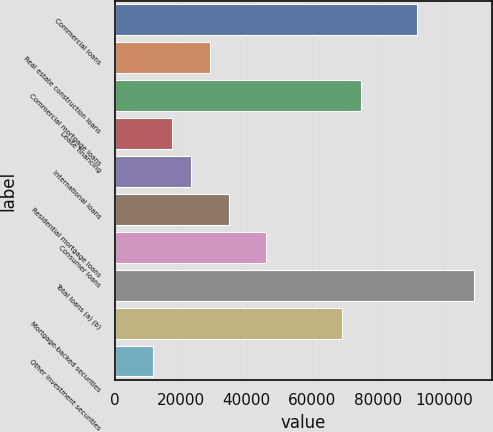<chart> <loc_0><loc_0><loc_500><loc_500><bar_chart><fcel>Commercial loans<fcel>Real estate construction loans<fcel>Commercial mortgage loans<fcel>Lease financing<fcel>International loans<fcel>Residential mortgage loans<fcel>Consumer loans<fcel>Total loans (a) (b)<fcel>Mortgage-backed securities<fcel>Other investment securities<nl><fcel>91892.4<fcel>28808.5<fcel>74687.7<fcel>17338.7<fcel>23073.6<fcel>34543.4<fcel>46013.2<fcel>109097<fcel>68952.8<fcel>11603.8<nl></chart> 